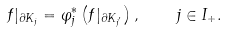<formula> <loc_0><loc_0><loc_500><loc_500>f | _ { \partial K _ { j } } = \varphi _ { j } ^ { * } \left ( f | _ { \partial K _ { j ^ { \prime } } } \right ) , \quad j \in I _ { + } .</formula> 